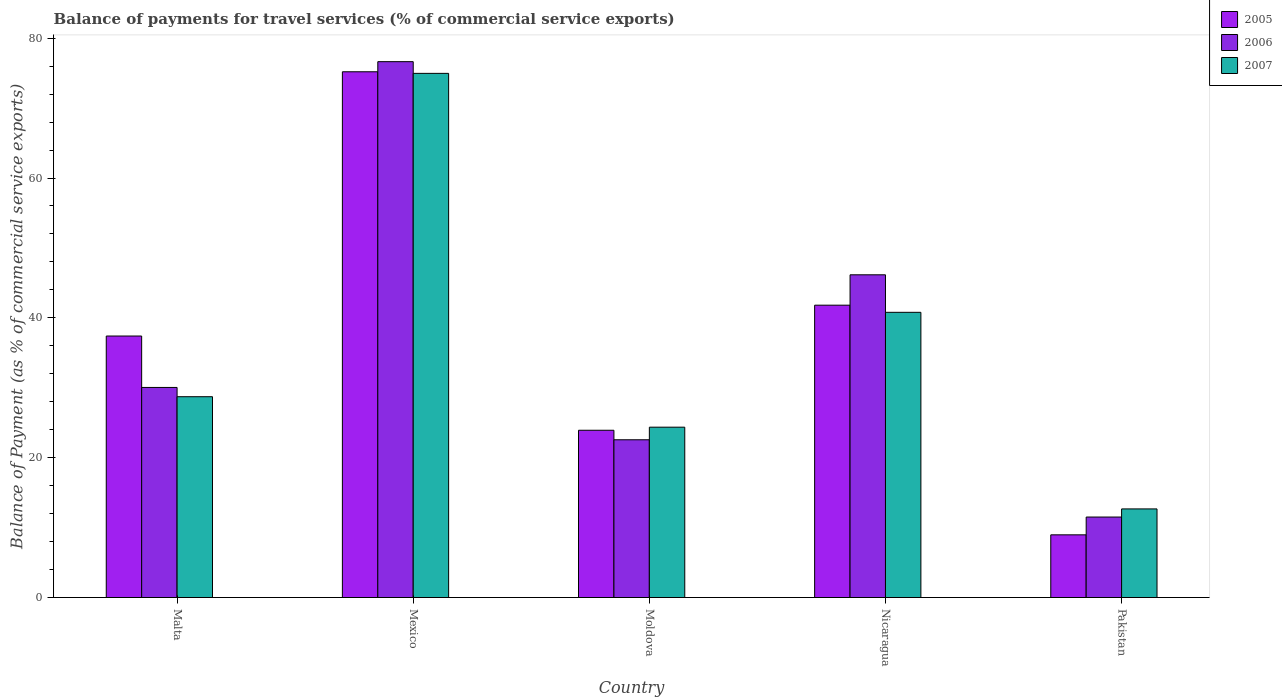How many different coloured bars are there?
Keep it short and to the point. 3. How many groups of bars are there?
Provide a succinct answer. 5. Are the number of bars per tick equal to the number of legend labels?
Provide a succinct answer. Yes. Are the number of bars on each tick of the X-axis equal?
Give a very brief answer. Yes. How many bars are there on the 2nd tick from the right?
Provide a short and direct response. 3. In how many cases, is the number of bars for a given country not equal to the number of legend labels?
Make the answer very short. 0. What is the balance of payments for travel services in 2006 in Pakistan?
Provide a short and direct response. 11.51. Across all countries, what is the maximum balance of payments for travel services in 2005?
Provide a succinct answer. 75.19. Across all countries, what is the minimum balance of payments for travel services in 2005?
Keep it short and to the point. 8.97. In which country was the balance of payments for travel services in 2006 maximum?
Give a very brief answer. Mexico. In which country was the balance of payments for travel services in 2005 minimum?
Give a very brief answer. Pakistan. What is the total balance of payments for travel services in 2007 in the graph?
Ensure brevity in your answer.  181.51. What is the difference between the balance of payments for travel services in 2006 in Malta and that in Moldova?
Your answer should be very brief. 7.48. What is the difference between the balance of payments for travel services in 2007 in Nicaragua and the balance of payments for travel services in 2006 in Moldova?
Provide a succinct answer. 18.23. What is the average balance of payments for travel services in 2006 per country?
Your response must be concise. 37.38. What is the difference between the balance of payments for travel services of/in 2007 and balance of payments for travel services of/in 2006 in Nicaragua?
Provide a succinct answer. -5.37. What is the ratio of the balance of payments for travel services in 2007 in Mexico to that in Moldova?
Your answer should be very brief. 3.08. Is the difference between the balance of payments for travel services in 2007 in Moldova and Pakistan greater than the difference between the balance of payments for travel services in 2006 in Moldova and Pakistan?
Offer a terse response. Yes. What is the difference between the highest and the second highest balance of payments for travel services in 2005?
Ensure brevity in your answer.  -33.38. What is the difference between the highest and the lowest balance of payments for travel services in 2006?
Your answer should be very brief. 65.13. In how many countries, is the balance of payments for travel services in 2005 greater than the average balance of payments for travel services in 2005 taken over all countries?
Offer a terse response. 2. Is it the case that in every country, the sum of the balance of payments for travel services in 2006 and balance of payments for travel services in 2005 is greater than the balance of payments for travel services in 2007?
Offer a terse response. Yes. How many bars are there?
Offer a terse response. 15. How many countries are there in the graph?
Ensure brevity in your answer.  5. What is the difference between two consecutive major ticks on the Y-axis?
Ensure brevity in your answer.  20. Does the graph contain grids?
Make the answer very short. No. How are the legend labels stacked?
Your response must be concise. Vertical. What is the title of the graph?
Ensure brevity in your answer.  Balance of payments for travel services (% of commercial service exports). What is the label or title of the X-axis?
Your response must be concise. Country. What is the label or title of the Y-axis?
Make the answer very short. Balance of Payment (as % of commercial service exports). What is the Balance of Payment (as % of commercial service exports) in 2005 in Malta?
Your answer should be compact. 37.4. What is the Balance of Payment (as % of commercial service exports) in 2006 in Malta?
Provide a succinct answer. 30.05. What is the Balance of Payment (as % of commercial service exports) of 2007 in Malta?
Ensure brevity in your answer.  28.72. What is the Balance of Payment (as % of commercial service exports) of 2005 in Mexico?
Offer a very short reply. 75.19. What is the Balance of Payment (as % of commercial service exports) in 2006 in Mexico?
Your answer should be compact. 76.64. What is the Balance of Payment (as % of commercial service exports) in 2007 in Mexico?
Your answer should be very brief. 74.97. What is the Balance of Payment (as % of commercial service exports) of 2005 in Moldova?
Offer a terse response. 23.92. What is the Balance of Payment (as % of commercial service exports) of 2006 in Moldova?
Your response must be concise. 22.56. What is the Balance of Payment (as % of commercial service exports) of 2007 in Moldova?
Offer a very short reply. 24.36. What is the Balance of Payment (as % of commercial service exports) in 2005 in Nicaragua?
Keep it short and to the point. 41.81. What is the Balance of Payment (as % of commercial service exports) in 2006 in Nicaragua?
Give a very brief answer. 46.16. What is the Balance of Payment (as % of commercial service exports) in 2007 in Nicaragua?
Your response must be concise. 40.79. What is the Balance of Payment (as % of commercial service exports) of 2005 in Pakistan?
Your response must be concise. 8.97. What is the Balance of Payment (as % of commercial service exports) of 2006 in Pakistan?
Ensure brevity in your answer.  11.51. What is the Balance of Payment (as % of commercial service exports) of 2007 in Pakistan?
Offer a terse response. 12.67. Across all countries, what is the maximum Balance of Payment (as % of commercial service exports) of 2005?
Provide a succinct answer. 75.19. Across all countries, what is the maximum Balance of Payment (as % of commercial service exports) in 2006?
Offer a terse response. 76.64. Across all countries, what is the maximum Balance of Payment (as % of commercial service exports) in 2007?
Ensure brevity in your answer.  74.97. Across all countries, what is the minimum Balance of Payment (as % of commercial service exports) of 2005?
Your answer should be very brief. 8.97. Across all countries, what is the minimum Balance of Payment (as % of commercial service exports) in 2006?
Give a very brief answer. 11.51. Across all countries, what is the minimum Balance of Payment (as % of commercial service exports) of 2007?
Keep it short and to the point. 12.67. What is the total Balance of Payment (as % of commercial service exports) of 2005 in the graph?
Your answer should be very brief. 187.3. What is the total Balance of Payment (as % of commercial service exports) of 2006 in the graph?
Offer a terse response. 186.92. What is the total Balance of Payment (as % of commercial service exports) of 2007 in the graph?
Make the answer very short. 181.51. What is the difference between the Balance of Payment (as % of commercial service exports) in 2005 in Malta and that in Mexico?
Offer a terse response. -37.79. What is the difference between the Balance of Payment (as % of commercial service exports) of 2006 in Malta and that in Mexico?
Ensure brevity in your answer.  -46.59. What is the difference between the Balance of Payment (as % of commercial service exports) of 2007 in Malta and that in Mexico?
Offer a terse response. -46.24. What is the difference between the Balance of Payment (as % of commercial service exports) of 2005 in Malta and that in Moldova?
Make the answer very short. 13.48. What is the difference between the Balance of Payment (as % of commercial service exports) in 2006 in Malta and that in Moldova?
Offer a terse response. 7.48. What is the difference between the Balance of Payment (as % of commercial service exports) of 2007 in Malta and that in Moldova?
Your response must be concise. 4.36. What is the difference between the Balance of Payment (as % of commercial service exports) of 2005 in Malta and that in Nicaragua?
Your response must be concise. -4.41. What is the difference between the Balance of Payment (as % of commercial service exports) in 2006 in Malta and that in Nicaragua?
Provide a succinct answer. -16.11. What is the difference between the Balance of Payment (as % of commercial service exports) in 2007 in Malta and that in Nicaragua?
Offer a very short reply. -12.07. What is the difference between the Balance of Payment (as % of commercial service exports) of 2005 in Malta and that in Pakistan?
Your answer should be very brief. 28.43. What is the difference between the Balance of Payment (as % of commercial service exports) in 2006 in Malta and that in Pakistan?
Offer a very short reply. 18.53. What is the difference between the Balance of Payment (as % of commercial service exports) in 2007 in Malta and that in Pakistan?
Keep it short and to the point. 16.05. What is the difference between the Balance of Payment (as % of commercial service exports) in 2005 in Mexico and that in Moldova?
Provide a short and direct response. 51.27. What is the difference between the Balance of Payment (as % of commercial service exports) of 2006 in Mexico and that in Moldova?
Offer a terse response. 54.08. What is the difference between the Balance of Payment (as % of commercial service exports) in 2007 in Mexico and that in Moldova?
Ensure brevity in your answer.  50.6. What is the difference between the Balance of Payment (as % of commercial service exports) of 2005 in Mexico and that in Nicaragua?
Provide a short and direct response. 33.38. What is the difference between the Balance of Payment (as % of commercial service exports) in 2006 in Mexico and that in Nicaragua?
Offer a very short reply. 30.48. What is the difference between the Balance of Payment (as % of commercial service exports) of 2007 in Mexico and that in Nicaragua?
Your answer should be very brief. 34.18. What is the difference between the Balance of Payment (as % of commercial service exports) of 2005 in Mexico and that in Pakistan?
Your answer should be very brief. 66.23. What is the difference between the Balance of Payment (as % of commercial service exports) of 2006 in Mexico and that in Pakistan?
Offer a terse response. 65.13. What is the difference between the Balance of Payment (as % of commercial service exports) of 2007 in Mexico and that in Pakistan?
Give a very brief answer. 62.29. What is the difference between the Balance of Payment (as % of commercial service exports) in 2005 in Moldova and that in Nicaragua?
Ensure brevity in your answer.  -17.89. What is the difference between the Balance of Payment (as % of commercial service exports) in 2006 in Moldova and that in Nicaragua?
Give a very brief answer. -23.59. What is the difference between the Balance of Payment (as % of commercial service exports) in 2007 in Moldova and that in Nicaragua?
Offer a terse response. -16.43. What is the difference between the Balance of Payment (as % of commercial service exports) of 2005 in Moldova and that in Pakistan?
Your answer should be compact. 14.96. What is the difference between the Balance of Payment (as % of commercial service exports) in 2006 in Moldova and that in Pakistan?
Offer a very short reply. 11.05. What is the difference between the Balance of Payment (as % of commercial service exports) of 2007 in Moldova and that in Pakistan?
Give a very brief answer. 11.69. What is the difference between the Balance of Payment (as % of commercial service exports) of 2005 in Nicaragua and that in Pakistan?
Your answer should be very brief. 32.85. What is the difference between the Balance of Payment (as % of commercial service exports) in 2006 in Nicaragua and that in Pakistan?
Provide a succinct answer. 34.64. What is the difference between the Balance of Payment (as % of commercial service exports) of 2007 in Nicaragua and that in Pakistan?
Ensure brevity in your answer.  28.12. What is the difference between the Balance of Payment (as % of commercial service exports) in 2005 in Malta and the Balance of Payment (as % of commercial service exports) in 2006 in Mexico?
Give a very brief answer. -39.24. What is the difference between the Balance of Payment (as % of commercial service exports) in 2005 in Malta and the Balance of Payment (as % of commercial service exports) in 2007 in Mexico?
Ensure brevity in your answer.  -37.57. What is the difference between the Balance of Payment (as % of commercial service exports) in 2006 in Malta and the Balance of Payment (as % of commercial service exports) in 2007 in Mexico?
Provide a succinct answer. -44.92. What is the difference between the Balance of Payment (as % of commercial service exports) of 2005 in Malta and the Balance of Payment (as % of commercial service exports) of 2006 in Moldova?
Ensure brevity in your answer.  14.84. What is the difference between the Balance of Payment (as % of commercial service exports) in 2005 in Malta and the Balance of Payment (as % of commercial service exports) in 2007 in Moldova?
Your answer should be compact. 13.04. What is the difference between the Balance of Payment (as % of commercial service exports) of 2006 in Malta and the Balance of Payment (as % of commercial service exports) of 2007 in Moldova?
Your answer should be very brief. 5.68. What is the difference between the Balance of Payment (as % of commercial service exports) in 2005 in Malta and the Balance of Payment (as % of commercial service exports) in 2006 in Nicaragua?
Your answer should be very brief. -8.76. What is the difference between the Balance of Payment (as % of commercial service exports) in 2005 in Malta and the Balance of Payment (as % of commercial service exports) in 2007 in Nicaragua?
Offer a terse response. -3.39. What is the difference between the Balance of Payment (as % of commercial service exports) in 2006 in Malta and the Balance of Payment (as % of commercial service exports) in 2007 in Nicaragua?
Your answer should be very brief. -10.74. What is the difference between the Balance of Payment (as % of commercial service exports) of 2005 in Malta and the Balance of Payment (as % of commercial service exports) of 2006 in Pakistan?
Keep it short and to the point. 25.89. What is the difference between the Balance of Payment (as % of commercial service exports) in 2005 in Malta and the Balance of Payment (as % of commercial service exports) in 2007 in Pakistan?
Keep it short and to the point. 24.73. What is the difference between the Balance of Payment (as % of commercial service exports) of 2006 in Malta and the Balance of Payment (as % of commercial service exports) of 2007 in Pakistan?
Make the answer very short. 17.37. What is the difference between the Balance of Payment (as % of commercial service exports) in 2005 in Mexico and the Balance of Payment (as % of commercial service exports) in 2006 in Moldova?
Offer a terse response. 52.63. What is the difference between the Balance of Payment (as % of commercial service exports) in 2005 in Mexico and the Balance of Payment (as % of commercial service exports) in 2007 in Moldova?
Ensure brevity in your answer.  50.83. What is the difference between the Balance of Payment (as % of commercial service exports) of 2006 in Mexico and the Balance of Payment (as % of commercial service exports) of 2007 in Moldova?
Provide a short and direct response. 52.28. What is the difference between the Balance of Payment (as % of commercial service exports) in 2005 in Mexico and the Balance of Payment (as % of commercial service exports) in 2006 in Nicaragua?
Ensure brevity in your answer.  29.04. What is the difference between the Balance of Payment (as % of commercial service exports) in 2005 in Mexico and the Balance of Payment (as % of commercial service exports) in 2007 in Nicaragua?
Provide a succinct answer. 34.4. What is the difference between the Balance of Payment (as % of commercial service exports) in 2006 in Mexico and the Balance of Payment (as % of commercial service exports) in 2007 in Nicaragua?
Provide a succinct answer. 35.85. What is the difference between the Balance of Payment (as % of commercial service exports) of 2005 in Mexico and the Balance of Payment (as % of commercial service exports) of 2006 in Pakistan?
Keep it short and to the point. 63.68. What is the difference between the Balance of Payment (as % of commercial service exports) of 2005 in Mexico and the Balance of Payment (as % of commercial service exports) of 2007 in Pakistan?
Provide a succinct answer. 62.52. What is the difference between the Balance of Payment (as % of commercial service exports) of 2006 in Mexico and the Balance of Payment (as % of commercial service exports) of 2007 in Pakistan?
Give a very brief answer. 63.97. What is the difference between the Balance of Payment (as % of commercial service exports) in 2005 in Moldova and the Balance of Payment (as % of commercial service exports) in 2006 in Nicaragua?
Offer a terse response. -22.23. What is the difference between the Balance of Payment (as % of commercial service exports) in 2005 in Moldova and the Balance of Payment (as % of commercial service exports) in 2007 in Nicaragua?
Ensure brevity in your answer.  -16.87. What is the difference between the Balance of Payment (as % of commercial service exports) of 2006 in Moldova and the Balance of Payment (as % of commercial service exports) of 2007 in Nicaragua?
Ensure brevity in your answer.  -18.23. What is the difference between the Balance of Payment (as % of commercial service exports) in 2005 in Moldova and the Balance of Payment (as % of commercial service exports) in 2006 in Pakistan?
Keep it short and to the point. 12.41. What is the difference between the Balance of Payment (as % of commercial service exports) in 2005 in Moldova and the Balance of Payment (as % of commercial service exports) in 2007 in Pakistan?
Ensure brevity in your answer.  11.25. What is the difference between the Balance of Payment (as % of commercial service exports) of 2006 in Moldova and the Balance of Payment (as % of commercial service exports) of 2007 in Pakistan?
Give a very brief answer. 9.89. What is the difference between the Balance of Payment (as % of commercial service exports) in 2005 in Nicaragua and the Balance of Payment (as % of commercial service exports) in 2006 in Pakistan?
Keep it short and to the point. 30.3. What is the difference between the Balance of Payment (as % of commercial service exports) of 2005 in Nicaragua and the Balance of Payment (as % of commercial service exports) of 2007 in Pakistan?
Offer a very short reply. 29.14. What is the difference between the Balance of Payment (as % of commercial service exports) of 2006 in Nicaragua and the Balance of Payment (as % of commercial service exports) of 2007 in Pakistan?
Offer a very short reply. 33.48. What is the average Balance of Payment (as % of commercial service exports) of 2005 per country?
Provide a succinct answer. 37.46. What is the average Balance of Payment (as % of commercial service exports) in 2006 per country?
Your response must be concise. 37.38. What is the average Balance of Payment (as % of commercial service exports) of 2007 per country?
Ensure brevity in your answer.  36.3. What is the difference between the Balance of Payment (as % of commercial service exports) in 2005 and Balance of Payment (as % of commercial service exports) in 2006 in Malta?
Offer a terse response. 7.35. What is the difference between the Balance of Payment (as % of commercial service exports) of 2005 and Balance of Payment (as % of commercial service exports) of 2007 in Malta?
Keep it short and to the point. 8.68. What is the difference between the Balance of Payment (as % of commercial service exports) in 2006 and Balance of Payment (as % of commercial service exports) in 2007 in Malta?
Provide a succinct answer. 1.32. What is the difference between the Balance of Payment (as % of commercial service exports) of 2005 and Balance of Payment (as % of commercial service exports) of 2006 in Mexico?
Provide a short and direct response. -1.45. What is the difference between the Balance of Payment (as % of commercial service exports) of 2005 and Balance of Payment (as % of commercial service exports) of 2007 in Mexico?
Give a very brief answer. 0.23. What is the difference between the Balance of Payment (as % of commercial service exports) of 2006 and Balance of Payment (as % of commercial service exports) of 2007 in Mexico?
Your answer should be compact. 1.67. What is the difference between the Balance of Payment (as % of commercial service exports) in 2005 and Balance of Payment (as % of commercial service exports) in 2006 in Moldova?
Give a very brief answer. 1.36. What is the difference between the Balance of Payment (as % of commercial service exports) of 2005 and Balance of Payment (as % of commercial service exports) of 2007 in Moldova?
Ensure brevity in your answer.  -0.44. What is the difference between the Balance of Payment (as % of commercial service exports) of 2006 and Balance of Payment (as % of commercial service exports) of 2007 in Moldova?
Your answer should be compact. -1.8. What is the difference between the Balance of Payment (as % of commercial service exports) in 2005 and Balance of Payment (as % of commercial service exports) in 2006 in Nicaragua?
Offer a very short reply. -4.34. What is the difference between the Balance of Payment (as % of commercial service exports) in 2005 and Balance of Payment (as % of commercial service exports) in 2007 in Nicaragua?
Offer a very short reply. 1.02. What is the difference between the Balance of Payment (as % of commercial service exports) in 2006 and Balance of Payment (as % of commercial service exports) in 2007 in Nicaragua?
Provide a succinct answer. 5.37. What is the difference between the Balance of Payment (as % of commercial service exports) in 2005 and Balance of Payment (as % of commercial service exports) in 2006 in Pakistan?
Your answer should be compact. -2.55. What is the difference between the Balance of Payment (as % of commercial service exports) in 2005 and Balance of Payment (as % of commercial service exports) in 2007 in Pakistan?
Your response must be concise. -3.71. What is the difference between the Balance of Payment (as % of commercial service exports) in 2006 and Balance of Payment (as % of commercial service exports) in 2007 in Pakistan?
Keep it short and to the point. -1.16. What is the ratio of the Balance of Payment (as % of commercial service exports) of 2005 in Malta to that in Mexico?
Your answer should be compact. 0.5. What is the ratio of the Balance of Payment (as % of commercial service exports) of 2006 in Malta to that in Mexico?
Your answer should be very brief. 0.39. What is the ratio of the Balance of Payment (as % of commercial service exports) of 2007 in Malta to that in Mexico?
Offer a terse response. 0.38. What is the ratio of the Balance of Payment (as % of commercial service exports) in 2005 in Malta to that in Moldova?
Your answer should be compact. 1.56. What is the ratio of the Balance of Payment (as % of commercial service exports) of 2006 in Malta to that in Moldova?
Make the answer very short. 1.33. What is the ratio of the Balance of Payment (as % of commercial service exports) in 2007 in Malta to that in Moldova?
Provide a short and direct response. 1.18. What is the ratio of the Balance of Payment (as % of commercial service exports) in 2005 in Malta to that in Nicaragua?
Make the answer very short. 0.89. What is the ratio of the Balance of Payment (as % of commercial service exports) in 2006 in Malta to that in Nicaragua?
Your answer should be compact. 0.65. What is the ratio of the Balance of Payment (as % of commercial service exports) in 2007 in Malta to that in Nicaragua?
Keep it short and to the point. 0.7. What is the ratio of the Balance of Payment (as % of commercial service exports) in 2005 in Malta to that in Pakistan?
Your response must be concise. 4.17. What is the ratio of the Balance of Payment (as % of commercial service exports) in 2006 in Malta to that in Pakistan?
Your answer should be very brief. 2.61. What is the ratio of the Balance of Payment (as % of commercial service exports) of 2007 in Malta to that in Pakistan?
Your answer should be very brief. 2.27. What is the ratio of the Balance of Payment (as % of commercial service exports) in 2005 in Mexico to that in Moldova?
Provide a succinct answer. 3.14. What is the ratio of the Balance of Payment (as % of commercial service exports) of 2006 in Mexico to that in Moldova?
Your answer should be compact. 3.4. What is the ratio of the Balance of Payment (as % of commercial service exports) of 2007 in Mexico to that in Moldova?
Your answer should be very brief. 3.08. What is the ratio of the Balance of Payment (as % of commercial service exports) of 2005 in Mexico to that in Nicaragua?
Provide a succinct answer. 1.8. What is the ratio of the Balance of Payment (as % of commercial service exports) of 2006 in Mexico to that in Nicaragua?
Provide a short and direct response. 1.66. What is the ratio of the Balance of Payment (as % of commercial service exports) in 2007 in Mexico to that in Nicaragua?
Give a very brief answer. 1.84. What is the ratio of the Balance of Payment (as % of commercial service exports) in 2005 in Mexico to that in Pakistan?
Your response must be concise. 8.39. What is the ratio of the Balance of Payment (as % of commercial service exports) of 2006 in Mexico to that in Pakistan?
Provide a succinct answer. 6.66. What is the ratio of the Balance of Payment (as % of commercial service exports) of 2007 in Mexico to that in Pakistan?
Make the answer very short. 5.92. What is the ratio of the Balance of Payment (as % of commercial service exports) of 2005 in Moldova to that in Nicaragua?
Ensure brevity in your answer.  0.57. What is the ratio of the Balance of Payment (as % of commercial service exports) of 2006 in Moldova to that in Nicaragua?
Your answer should be compact. 0.49. What is the ratio of the Balance of Payment (as % of commercial service exports) in 2007 in Moldova to that in Nicaragua?
Your answer should be compact. 0.6. What is the ratio of the Balance of Payment (as % of commercial service exports) of 2005 in Moldova to that in Pakistan?
Keep it short and to the point. 2.67. What is the ratio of the Balance of Payment (as % of commercial service exports) of 2006 in Moldova to that in Pakistan?
Offer a very short reply. 1.96. What is the ratio of the Balance of Payment (as % of commercial service exports) in 2007 in Moldova to that in Pakistan?
Make the answer very short. 1.92. What is the ratio of the Balance of Payment (as % of commercial service exports) in 2005 in Nicaragua to that in Pakistan?
Make the answer very short. 4.66. What is the ratio of the Balance of Payment (as % of commercial service exports) of 2006 in Nicaragua to that in Pakistan?
Ensure brevity in your answer.  4.01. What is the ratio of the Balance of Payment (as % of commercial service exports) in 2007 in Nicaragua to that in Pakistan?
Ensure brevity in your answer.  3.22. What is the difference between the highest and the second highest Balance of Payment (as % of commercial service exports) of 2005?
Give a very brief answer. 33.38. What is the difference between the highest and the second highest Balance of Payment (as % of commercial service exports) of 2006?
Ensure brevity in your answer.  30.48. What is the difference between the highest and the second highest Balance of Payment (as % of commercial service exports) in 2007?
Your answer should be compact. 34.18. What is the difference between the highest and the lowest Balance of Payment (as % of commercial service exports) in 2005?
Provide a short and direct response. 66.23. What is the difference between the highest and the lowest Balance of Payment (as % of commercial service exports) of 2006?
Provide a succinct answer. 65.13. What is the difference between the highest and the lowest Balance of Payment (as % of commercial service exports) of 2007?
Keep it short and to the point. 62.29. 